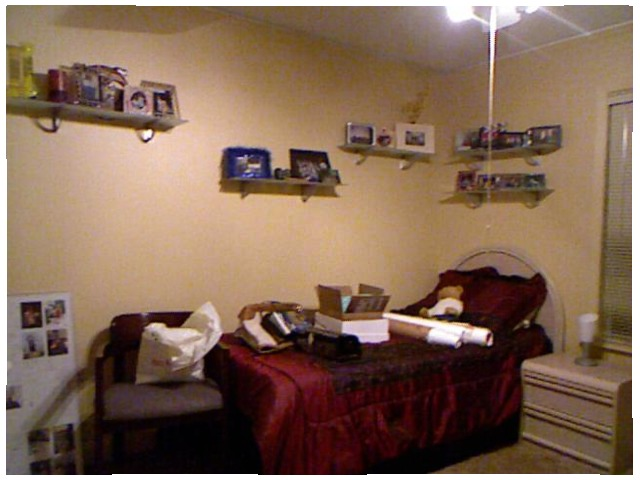<image>
Can you confirm if the shelves is under the bed? No. The shelves is not positioned under the bed. The vertical relationship between these objects is different. 